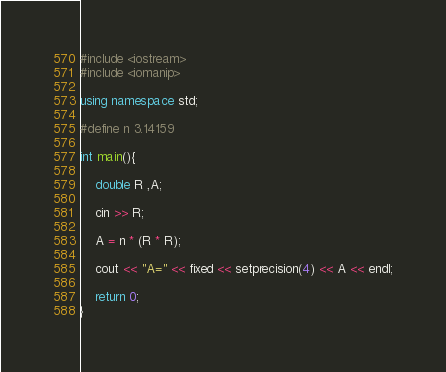Convert code to text. <code><loc_0><loc_0><loc_500><loc_500><_C++_>#include <iostream>
#include <iomanip>

using namespace std;

#define n 3.14159

int main(){

    double R ,A;

    cin >> R;

    A = n * (R * R);

    cout << "A=" << fixed << setprecision(4) << A << endl;

    return 0;
}</code> 